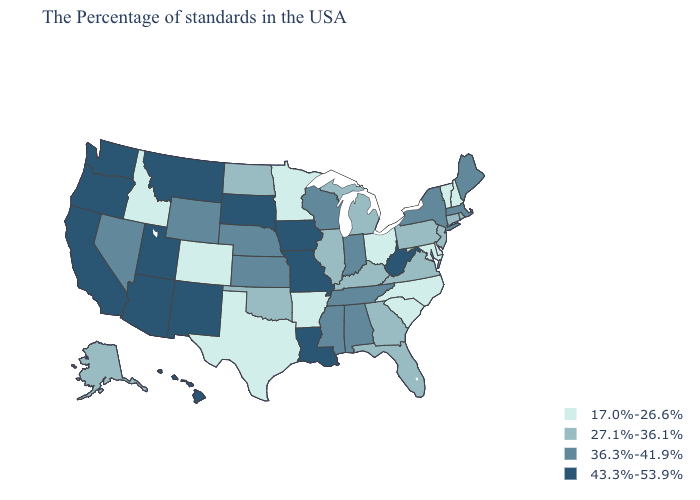Does Colorado have the highest value in the West?
Short answer required. No. Does Vermont have the lowest value in the Northeast?
Answer briefly. Yes. Name the states that have a value in the range 17.0%-26.6%?
Be succinct. New Hampshire, Vermont, Delaware, Maryland, North Carolina, South Carolina, Ohio, Arkansas, Minnesota, Texas, Colorado, Idaho. Among the states that border Washington , does Oregon have the lowest value?
Concise answer only. No. Does Washington have the highest value in the USA?
Concise answer only. Yes. Does the map have missing data?
Answer briefly. No. What is the value of Tennessee?
Write a very short answer. 36.3%-41.9%. Name the states that have a value in the range 27.1%-36.1%?
Give a very brief answer. Rhode Island, Connecticut, New Jersey, Pennsylvania, Virginia, Florida, Georgia, Michigan, Kentucky, Illinois, Oklahoma, North Dakota, Alaska. Does California have the same value as Iowa?
Concise answer only. Yes. Does Arizona have the highest value in the West?
Be succinct. Yes. Does Washington have a higher value than Arkansas?
Quick response, please. Yes. What is the value of Arkansas?
Answer briefly. 17.0%-26.6%. Among the states that border New Mexico , which have the lowest value?
Give a very brief answer. Texas, Colorado. Which states hav the highest value in the Northeast?
Concise answer only. Maine, Massachusetts, New York. 